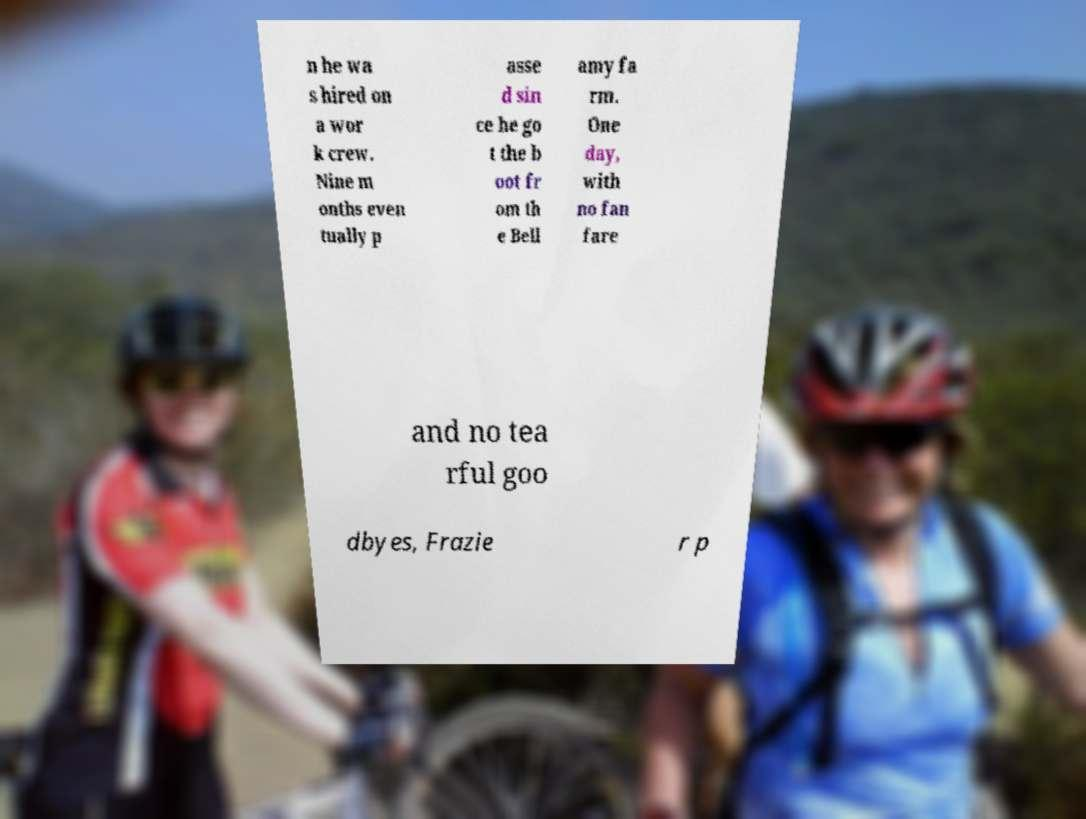Can you read and provide the text displayed in the image?This photo seems to have some interesting text. Can you extract and type it out for me? n he wa s hired on a wor k crew. Nine m onths even tually p asse d sin ce he go t the b oot fr om th e Bell amy fa rm. One day, with no fan fare and no tea rful goo dbyes, Frazie r p 